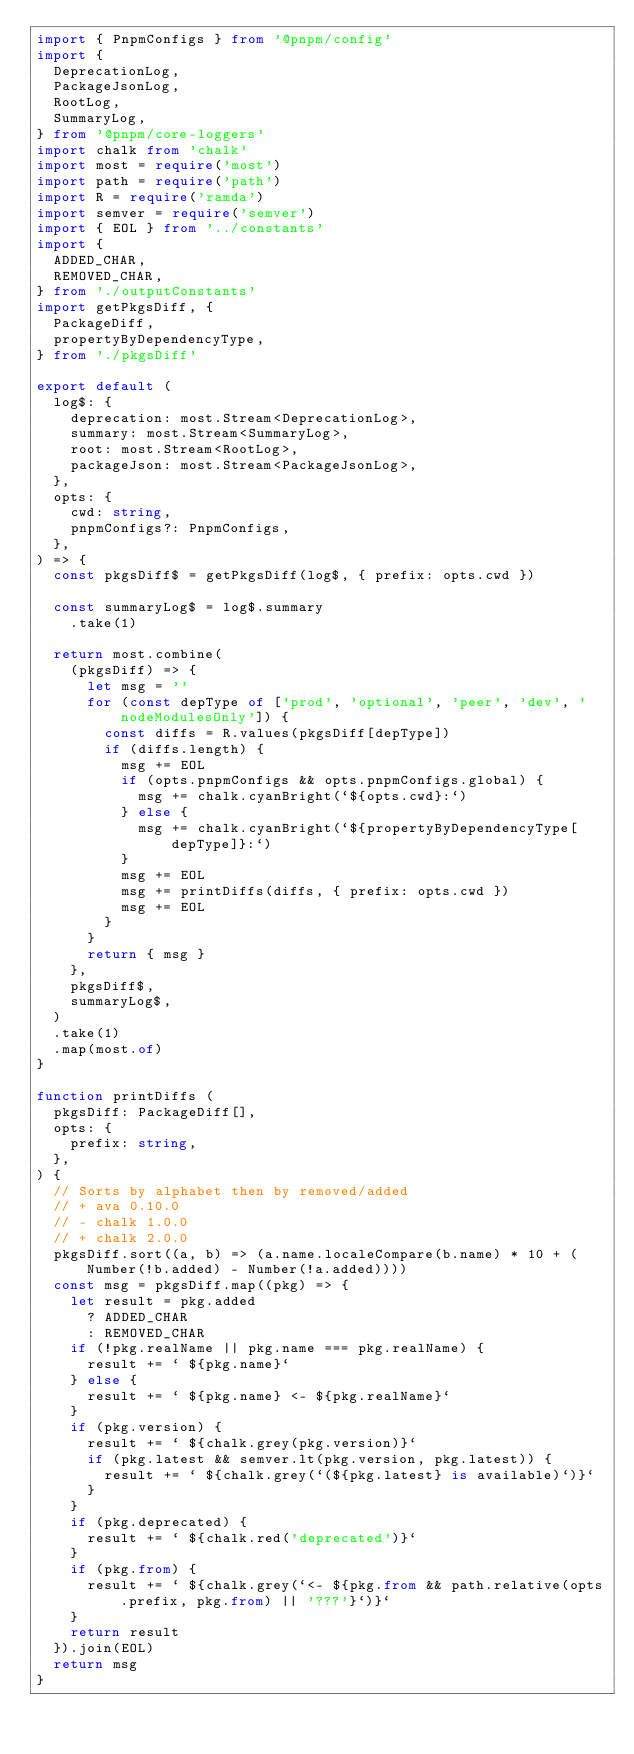Convert code to text. <code><loc_0><loc_0><loc_500><loc_500><_TypeScript_>import { PnpmConfigs } from '@pnpm/config'
import {
  DeprecationLog,
  PackageJsonLog,
  RootLog,
  SummaryLog,
} from '@pnpm/core-loggers'
import chalk from 'chalk'
import most = require('most')
import path = require('path')
import R = require('ramda')
import semver = require('semver')
import { EOL } from '../constants'
import {
  ADDED_CHAR,
  REMOVED_CHAR,
} from './outputConstants'
import getPkgsDiff, {
  PackageDiff,
  propertyByDependencyType,
} from './pkgsDiff'

export default (
  log$: {
    deprecation: most.Stream<DeprecationLog>,
    summary: most.Stream<SummaryLog>,
    root: most.Stream<RootLog>,
    packageJson: most.Stream<PackageJsonLog>,
  },
  opts: {
    cwd: string,
    pnpmConfigs?: PnpmConfigs,
  },
) => {
  const pkgsDiff$ = getPkgsDiff(log$, { prefix: opts.cwd })

  const summaryLog$ = log$.summary
    .take(1)

  return most.combine(
    (pkgsDiff) => {
      let msg = ''
      for (const depType of ['prod', 'optional', 'peer', 'dev', 'nodeModulesOnly']) {
        const diffs = R.values(pkgsDiff[depType])
        if (diffs.length) {
          msg += EOL
          if (opts.pnpmConfigs && opts.pnpmConfigs.global) {
            msg += chalk.cyanBright(`${opts.cwd}:`)
          } else {
            msg += chalk.cyanBright(`${propertyByDependencyType[depType]}:`)
          }
          msg += EOL
          msg += printDiffs(diffs, { prefix: opts.cwd })
          msg += EOL
        }
      }
      return { msg }
    },
    pkgsDiff$,
    summaryLog$,
  )
  .take(1)
  .map(most.of)
}

function printDiffs (
  pkgsDiff: PackageDiff[],
  opts: {
    prefix: string,
  },
) {
  // Sorts by alphabet then by removed/added
  // + ava 0.10.0
  // - chalk 1.0.0
  // + chalk 2.0.0
  pkgsDiff.sort((a, b) => (a.name.localeCompare(b.name) * 10 + (Number(!b.added) - Number(!a.added))))
  const msg = pkgsDiff.map((pkg) => {
    let result = pkg.added
      ? ADDED_CHAR
      : REMOVED_CHAR
    if (!pkg.realName || pkg.name === pkg.realName) {
      result += ` ${pkg.name}`
    } else {
      result += ` ${pkg.name} <- ${pkg.realName}`
    }
    if (pkg.version) {
      result += ` ${chalk.grey(pkg.version)}`
      if (pkg.latest && semver.lt(pkg.version, pkg.latest)) {
        result += ` ${chalk.grey(`(${pkg.latest} is available)`)}`
      }
    }
    if (pkg.deprecated) {
      result += ` ${chalk.red('deprecated')}`
    }
    if (pkg.from) {
      result += ` ${chalk.grey(`<- ${pkg.from && path.relative(opts.prefix, pkg.from) || '???'}`)}`
    }
    return result
  }).join(EOL)
  return msg
}
</code> 